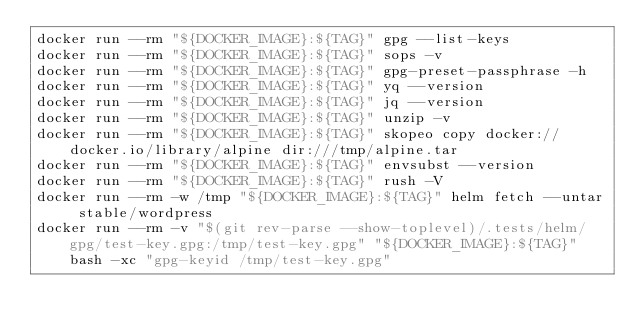<code> <loc_0><loc_0><loc_500><loc_500><_Bash_>docker run --rm "${DOCKER_IMAGE}:${TAG}" gpg --list-keys
docker run --rm "${DOCKER_IMAGE}:${TAG}" sops -v
docker run --rm "${DOCKER_IMAGE}:${TAG}" gpg-preset-passphrase -h
docker run --rm "${DOCKER_IMAGE}:${TAG}" yq --version
docker run --rm "${DOCKER_IMAGE}:${TAG}" jq --version
docker run --rm "${DOCKER_IMAGE}:${TAG}" unzip -v
docker run --rm "${DOCKER_IMAGE}:${TAG}" skopeo copy docker://docker.io/library/alpine dir:///tmp/alpine.tar
docker run --rm "${DOCKER_IMAGE}:${TAG}" envsubst --version
docker run --rm "${DOCKER_IMAGE}:${TAG}" rush -V
docker run --rm -w /tmp "${DOCKER_IMAGE}:${TAG}" helm fetch --untar stable/wordpress
docker run --rm -v "$(git rev-parse --show-toplevel)/.tests/helm/gpg/test-key.gpg:/tmp/test-key.gpg" "${DOCKER_IMAGE}:${TAG}" bash -xc "gpg-keyid /tmp/test-key.gpg"
</code> 